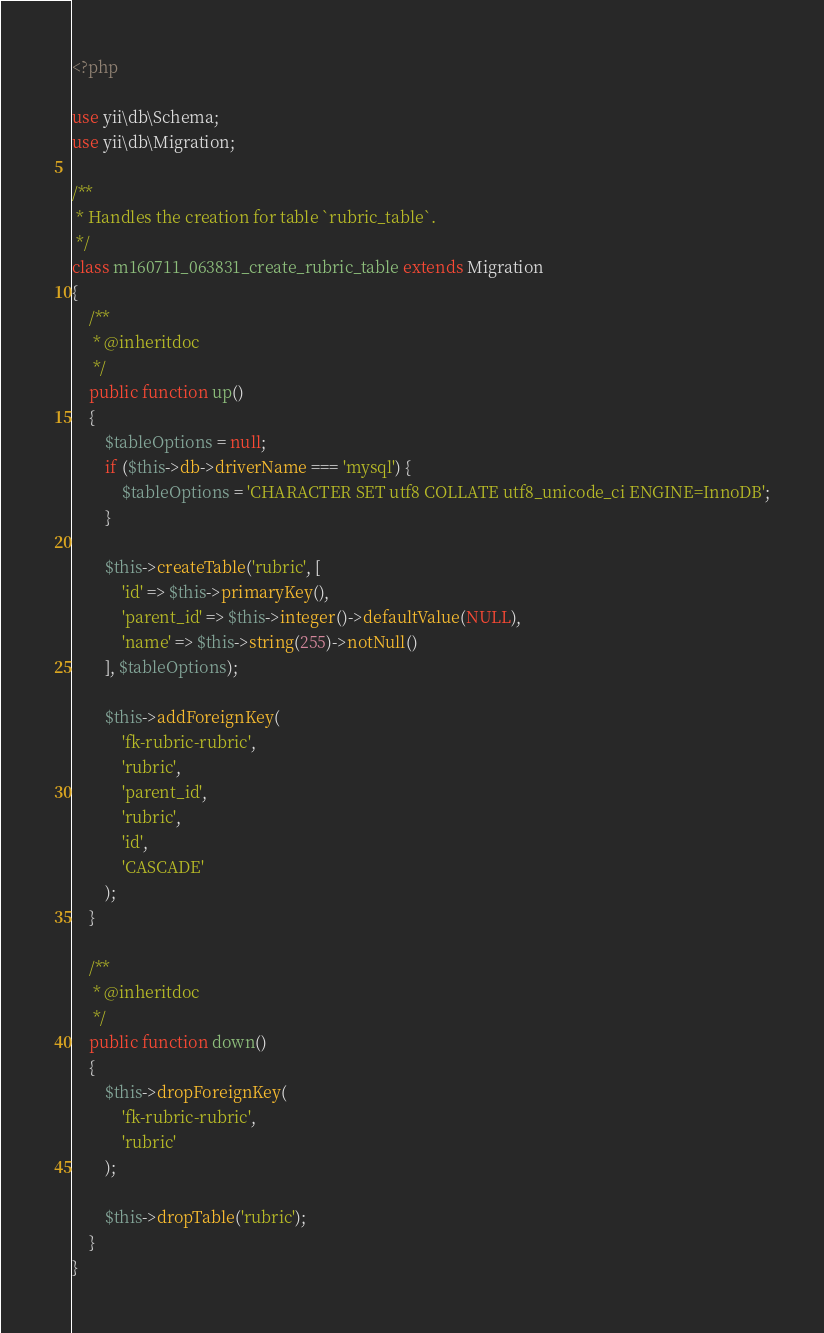<code> <loc_0><loc_0><loc_500><loc_500><_PHP_><?php

use yii\db\Schema;
use yii\db\Migration;

/**
 * Handles the creation for table `rubric_table`.
 */
class m160711_063831_create_rubric_table extends Migration
{
    /**
     * @inheritdoc
     */
    public function up()
    {
        $tableOptions = null;
        if ($this->db->driverName === 'mysql') {
            $tableOptions = 'CHARACTER SET utf8 COLLATE utf8_unicode_ci ENGINE=InnoDB';
        }

        $this->createTable('rubric', [
            'id' => $this->primaryKey(),
            'parent_id' => $this->integer()->defaultValue(NULL),
            'name' => $this->string(255)->notNull()
        ], $tableOptions);

        $this->addForeignKey(
            'fk-rubric-rubric',
            'rubric',
            'parent_id',
            'rubric',
            'id',
            'CASCADE'
        );
    }

    /**
     * @inheritdoc
     */
    public function down()
    {
        $this->dropForeignKey(
            'fk-rubric-rubric',
            'rubric'
        );

        $this->dropTable('rubric');
    }
}
</code> 